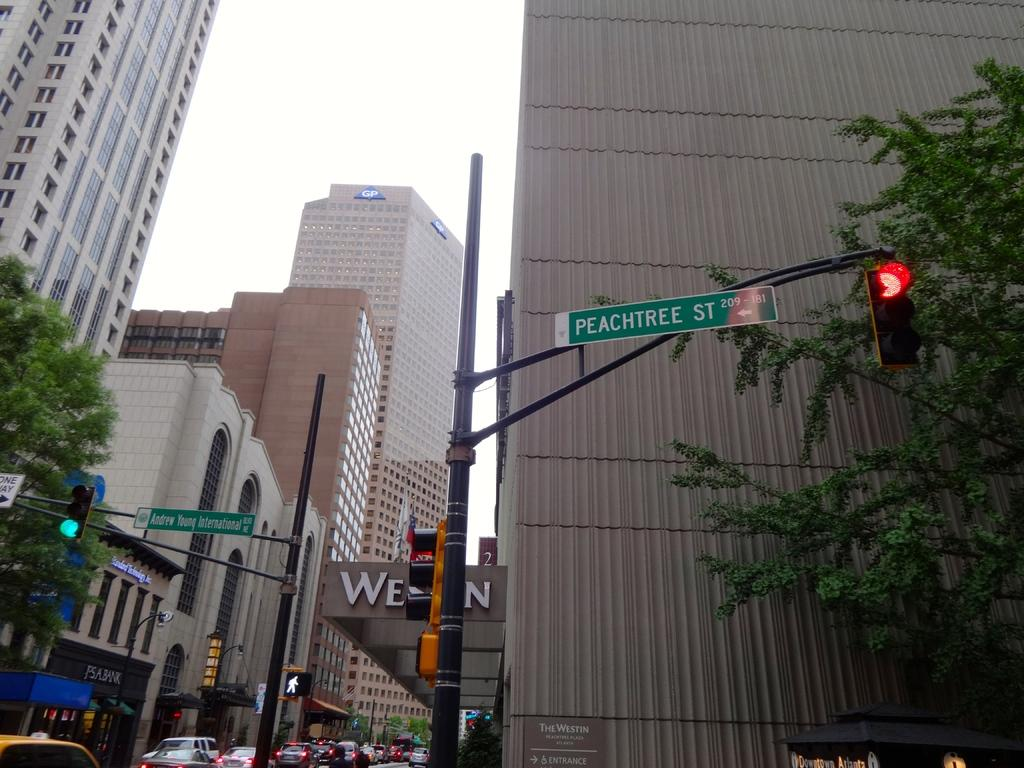Provide a one-sentence caption for the provided image. A city intersection is shown:  Peachtree Street to the right foreground, and Andrew Young International Boulevard to the left into the background. 